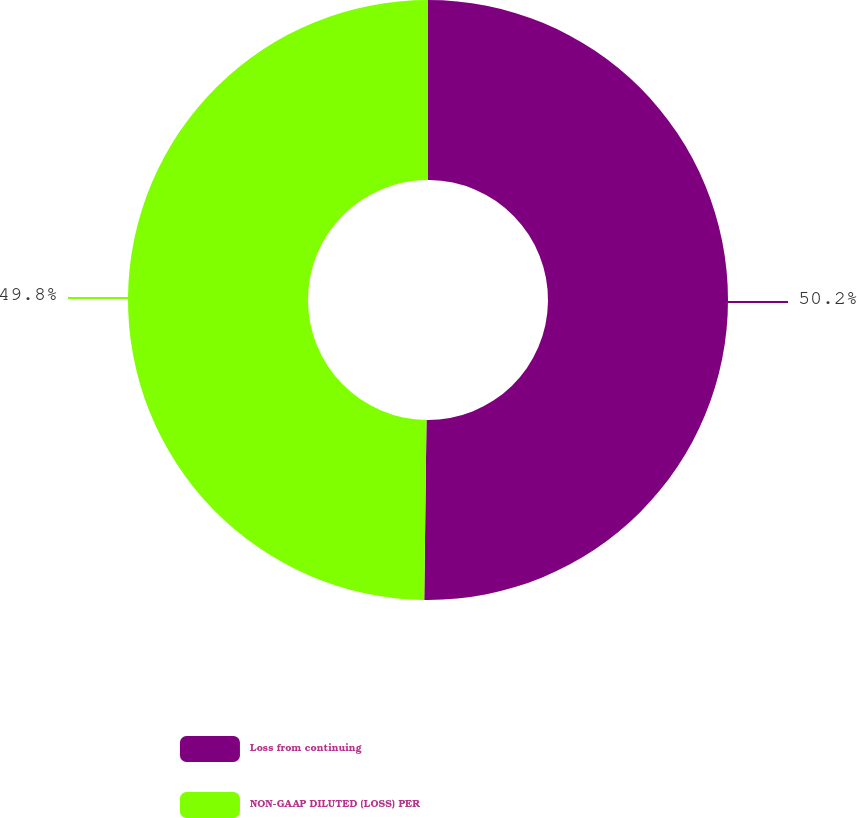<chart> <loc_0><loc_0><loc_500><loc_500><pie_chart><fcel>Loss from continuing<fcel>NON-GAAP DILUTED (LOSS) PER<nl><fcel>50.2%<fcel>49.8%<nl></chart> 